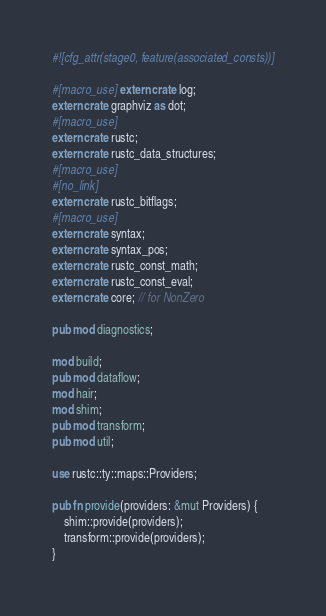<code> <loc_0><loc_0><loc_500><loc_500><_Rust_>#![cfg_attr(stage0, feature(associated_consts))]

#[macro_use] extern crate log;
extern crate graphviz as dot;
#[macro_use]
extern crate rustc;
extern crate rustc_data_structures;
#[macro_use]
#[no_link]
extern crate rustc_bitflags;
#[macro_use]
extern crate syntax;
extern crate syntax_pos;
extern crate rustc_const_math;
extern crate rustc_const_eval;
extern crate core; // for NonZero

pub mod diagnostics;

mod build;
pub mod dataflow;
mod hair;
mod shim;
pub mod transform;
pub mod util;

use rustc::ty::maps::Providers;

pub fn provide(providers: &mut Providers) {
    shim::provide(providers);
    transform::provide(providers);
}
</code> 